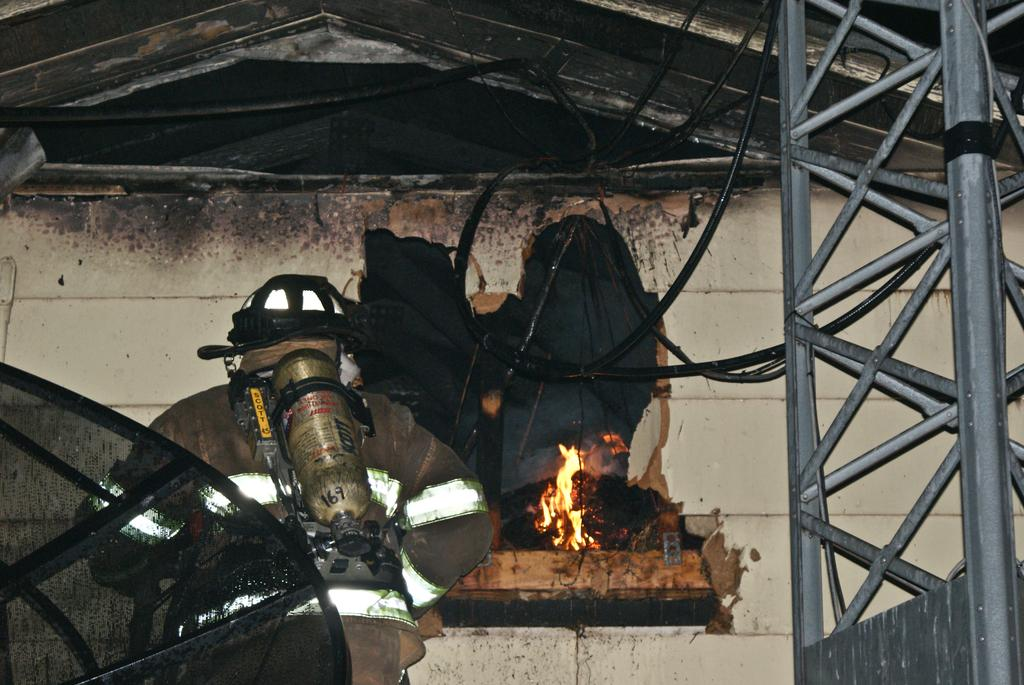What type of machine is present in the image? There is an electrical machine in the image. Where is the electrical machine located in relation to the wall? The electrical machine is close to a wall. What feature can be seen on top of the wall? There is a fireplace on top of the wall. What other structure is visible in the image? There is an iron pole tower in the image. What type of bedroom furniture can be seen in the image? There is no bedroom furniture present in the image. What class of students might be using the electrical machine in the image? The image does not provide any information about students or a class setting. 